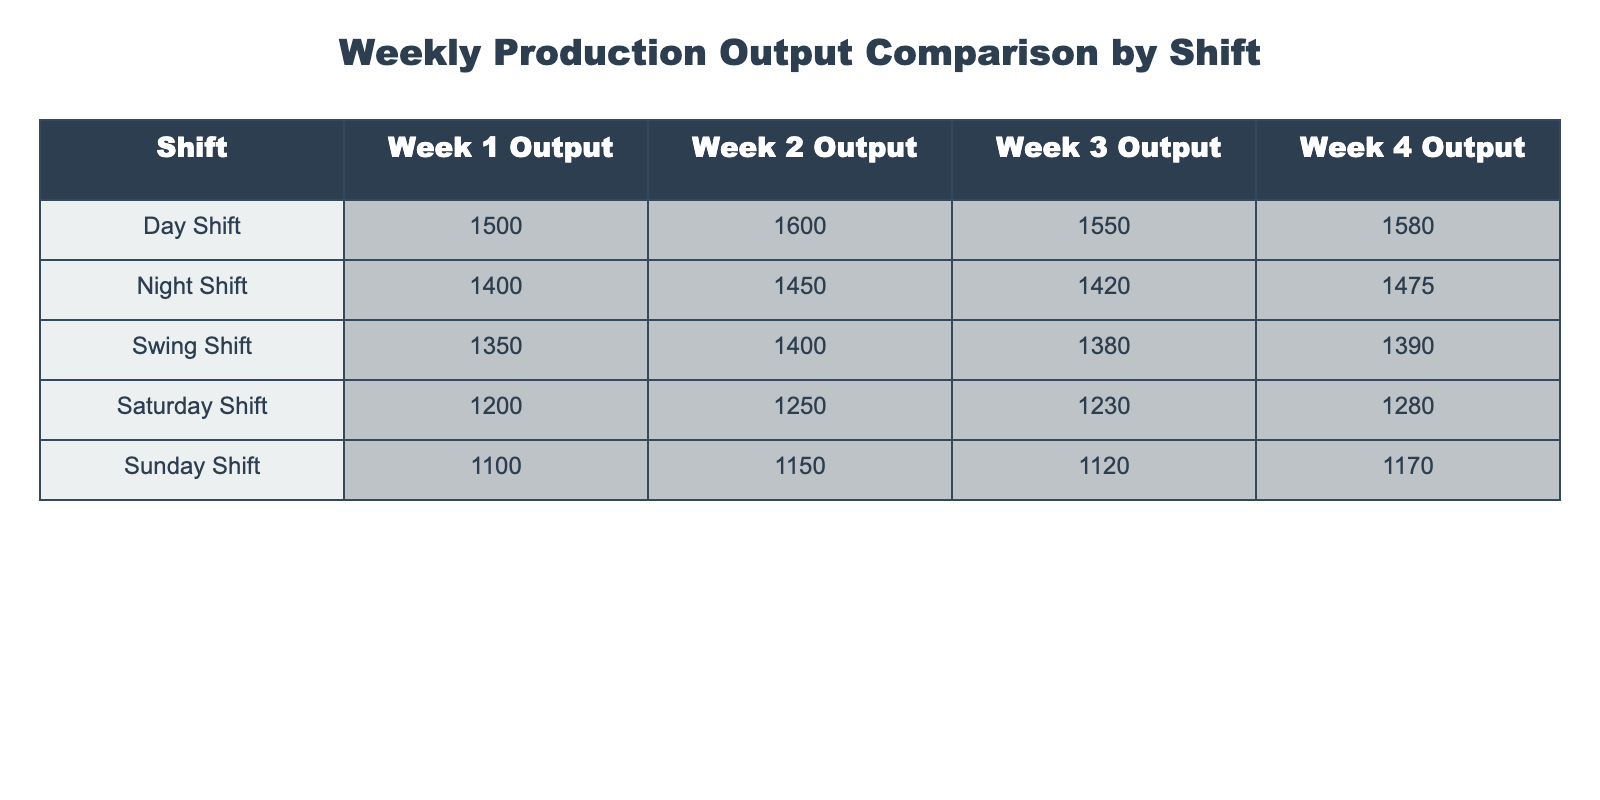What is the production output for the Day Shift in Week 3? According to the table, the production output for the Day Shift in Week 3 is directly stated as 1550.
Answer: 1550 Which shift had the highest production output in Week 4? By comparing the outputs in Week 4 for each shift, the Day Shift has the highest output at 1580.
Answer: Day Shift What is the average production output for the Night Shift over 4 weeks? The production outputs for the Night Shift over 4 weeks are 1400, 1450, 1420, and 1475. Summing these gives 5755, and averaging gives 5755/4 = 1438.75.
Answer: 1438.75 Which shift had the lowest output in Week 1? Referring to Week 1, the Saturday Shift had the lowest production output of 1200 compared to other shifts.
Answer: Saturday Shift What is the difference in production output between the Day Shift and Night Shift in Week 2? The production output for the Day Shift in Week 2 is 1600, and for the Night Shift, it is 1450. The difference is 1600 - 1450 = 150.
Answer: 150 How does the Swing Shift's output in Week 3 compare to its output in Week 1? The output for the Swing Shift in Week 3 is 1380, while in Week 1 it is 1350. The comparison shows an increase of 30.
Answer: Increased by 30 Which shift shows the most consistent production output across the 4 weeks? Analyzing the production outputs, the Sunday Shift shows values of 1100, 1150, 1120, and 1170, with differences of 50, 30, and 50 respectively, indicating more consistency than other shifts.
Answer: Sunday Shift What was the total production output for the Saturday Shift across all 4 weeks? The outputs for Saturday Shift are 1200, 1250, 1230, and 1280. Summing them gives 1200 + 1250 + 1230 + 1280 = 5010.
Answer: 5010 Is there a shift that consistently produced more than 1500 units each week? Looking at the data, the Day Shift produced more than 1500 units for all weeks: 1500, 1600, 1550, and 1580, confirming consistency above this threshold.
Answer: Yes Which shift had better production output performance in Week 1 compared to Week 3? Comparing Week 1 and Week 3 outputs, only the Swing Shift (Week 1: 1350, Week 3: 1380) improved, while all others either remained the same or decreased.
Answer: Swing Shift What is the median production output across all shifts in Week 2? Listing the outputs for Week 2: 1600 (Day), 1450 (Night), 1400 (Swing), 1250 (Saturday), and 1150 (Sunday), sorting gives 1150, 1250, 1400, 1450, 1600 - the median is 1400.
Answer: 1400 